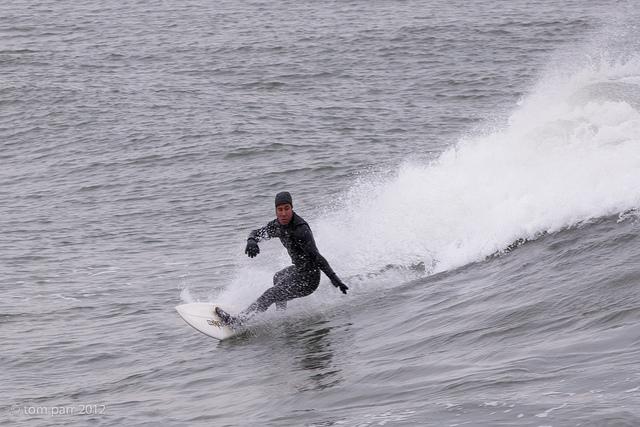Is this person wearing a wetsuit?
Keep it brief. Yes. Does the water look dangerous?
Short answer required. No. What is this man doing?
Keep it brief. Surfing. What is the man doing?
Concise answer only. Surfing. 